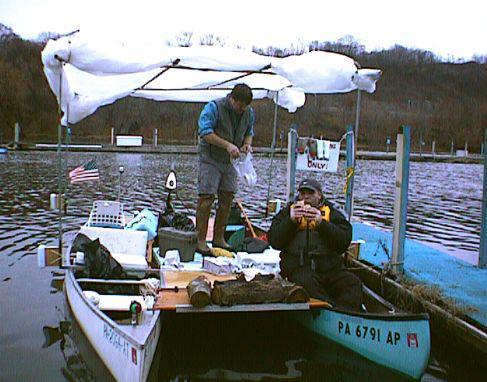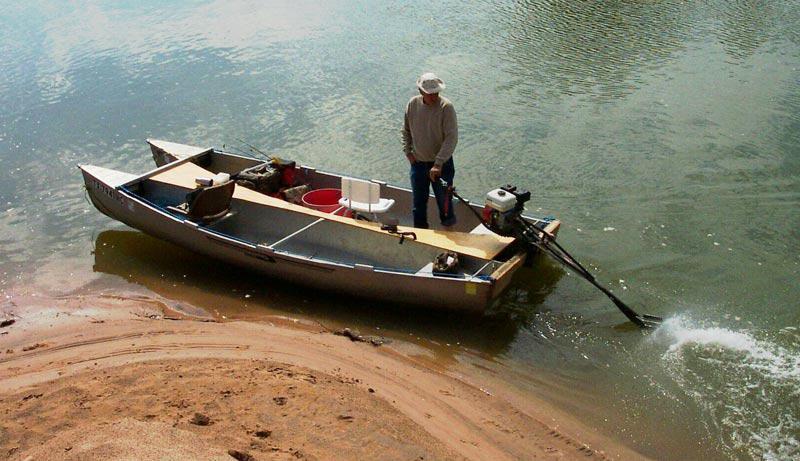The first image is the image on the left, the second image is the image on the right. For the images shown, is this caption "There is an American flag on the boat in the image on the left." true? Answer yes or no. Yes. The first image is the image on the left, the second image is the image on the right. Considering the images on both sides, is "Both images show multiple people inside a double-rigger canoe that is at least partially on the water." valid? Answer yes or no. No. 